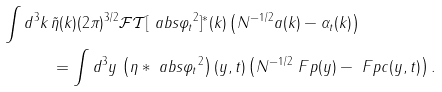Convert formula to latex. <formula><loc_0><loc_0><loc_500><loc_500>\int d ^ { 3 } k \, & \tilde { \eta } ( k ) ( 2 \pi ) ^ { 3 / 2 } \mathcal { F T } [ \ a b s { \varphi _ { t } } ^ { 2 } ] ^ { * } ( k ) \left ( N ^ { - 1 / 2 } a ( k ) - \alpha _ { t } ( k ) \right ) \\ & = \int d ^ { 3 } y \, \left ( \eta * \ a b s { \varphi _ { t } } ^ { 2 } \right ) ( y , t ) \left ( N ^ { - 1 / 2 } \ F p ( y ) - \ F p c ( y , t ) \right ) .</formula> 